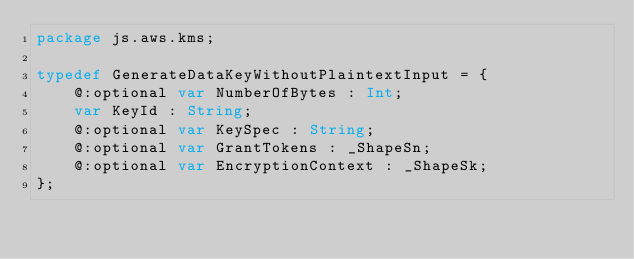Convert code to text. <code><loc_0><loc_0><loc_500><loc_500><_Haxe_>package js.aws.kms;

typedef GenerateDataKeyWithoutPlaintextInput = {
    @:optional var NumberOfBytes : Int;
    var KeyId : String;
    @:optional var KeySpec : String;
    @:optional var GrantTokens : _ShapeSn;
    @:optional var EncryptionContext : _ShapeSk;
};
</code> 